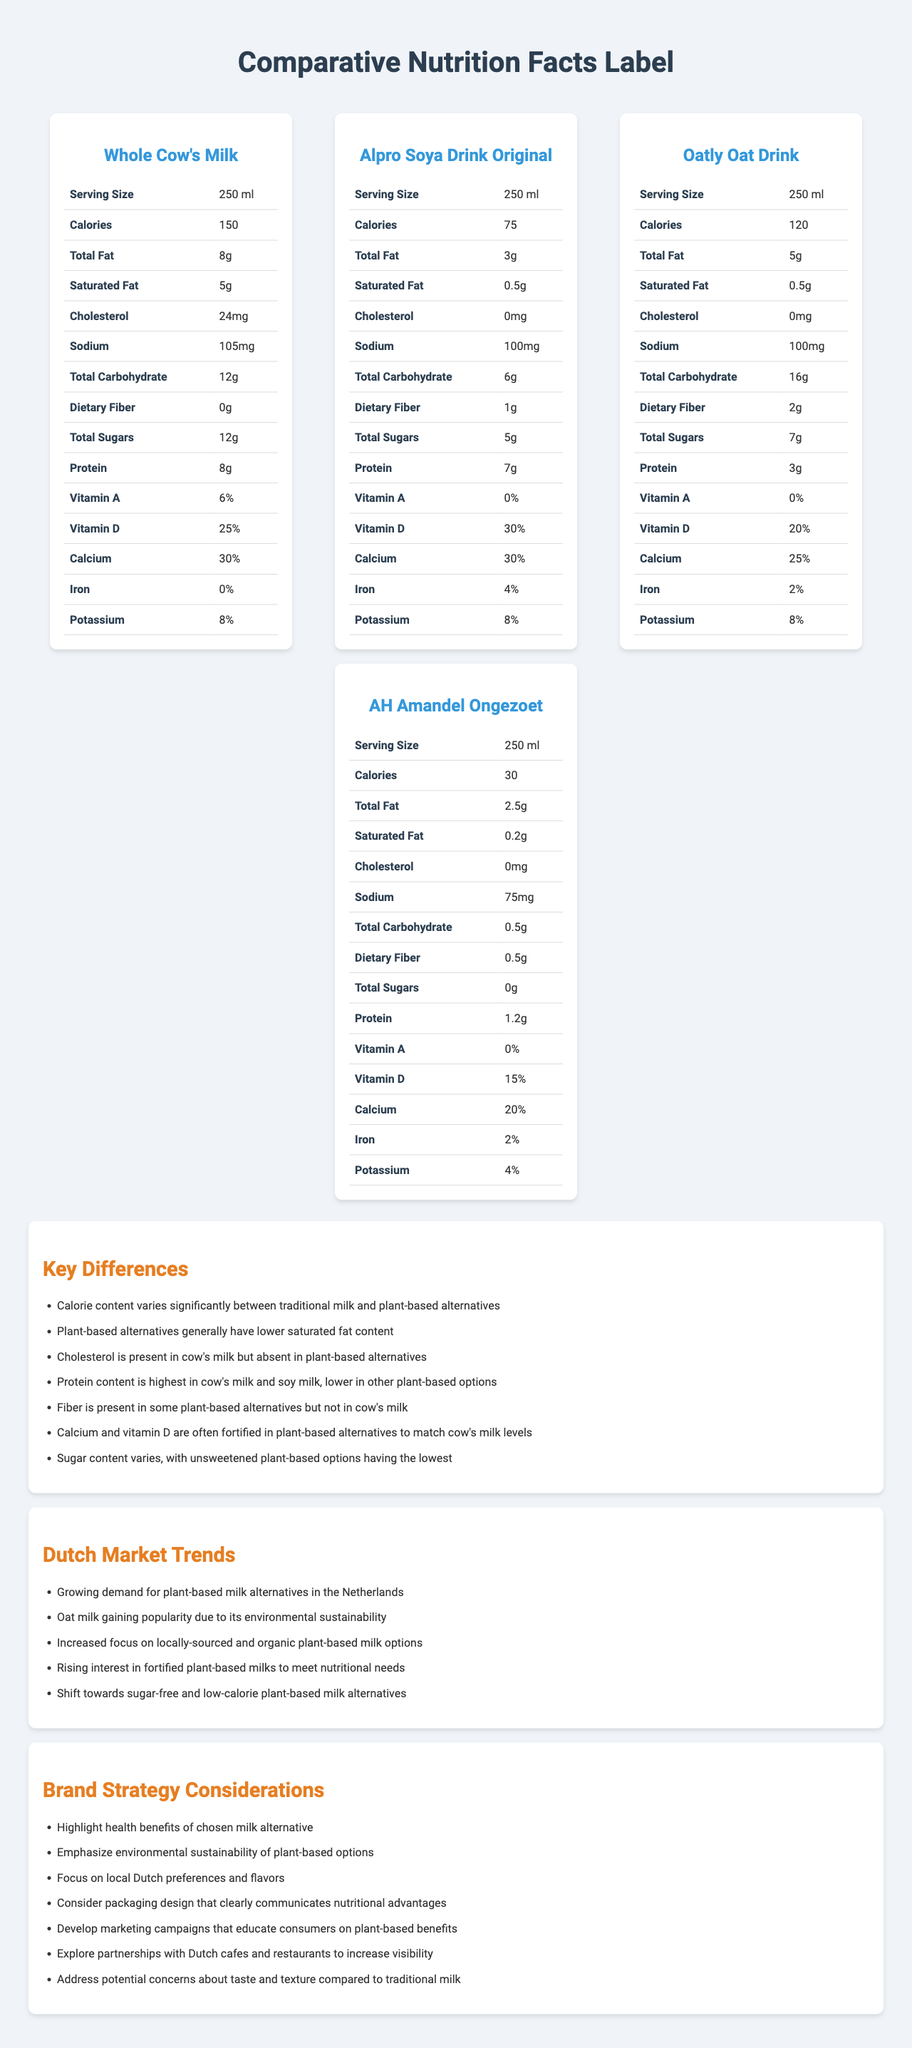What is the serving size for Whole Cow's Milk? The serving size is listed in the nutritional facts table for Whole Cow's Milk.
Answer: 250 ml Which plant-based alternative has the highest protein content? Alpro Soya Drink Original has 7g of protein per 250 ml serving, which is the highest among the plant-based alternatives listed.
Answer: Alpro Soya Drink Original How much dietary fiber does Oatly Oat Drink contain? According to the nutritional table for Oatly Oat Drink, it contains 2g of dietary fiber per serving.
Answer: 2g Does Whole Cow's Milk contain any dietary fiber? The nutritional table for Whole Cow's Milk lists dietary fiber as 0g.
Answer: No What is the total fat content of AH Amandel Ongezoet? The nutritional facts show that AH Amandel Ongezoet contains 2.5g of total fat per serving.
Answer: 2.5g Which milk option has the lowest calorie content? A. Whole Cow's Milk B. Alpro Soya Drink Original C. Oatly Oat Drink D. AH Amandel Ongezoet AH Amandel Ongezoet has 30 calories per serving, the lowest among the options listed.
Answer: D Which of the following milk alternatives is sodium content the lowest in? A. Whole Cow's Milk B. Alpro Soya Drink Original C. Oatly Oat Drink D. AH Amandel Ongezoet AH Amandel Ongezoet contains 75mg of sodium, the lowest among the listed products.
Answer: D Is cholesterol present in Oatly Oat Drink? The document states that cholesterol is 0mg in Oatly Oat Drink.
Answer: No What are the main nutritional differences between traditional milk and plant-based alternatives? The key differences section provides a detailed comparison highlighting these points.
Answer: Calorie variation, lower saturated fat, no cholesterol, higher fiber in some alternatives, differences in protein levels, fortification with calcium and vitamin D, and variable sugar content Describe the document. The document includes nutritional tables for Whole Cow's Milk and three plant-based alternatives (Alpro Soya Drink Original, Oatly Oat Drink, AH Amandel Ongezoet), explains key nutritional differences, discusses Dutch market trends for plant-based milks, and provides brand strategy considerations.
Answer: A comparative analysis of the nutrition facts labeling for Whole Cow's Milk and various plant-based milk alternatives, noting key differences, Dutch market trends, and brand strategy considerations. What is the main market trend for plant-based milk in the Netherlands? The Dutch market trends section lists "Growing demand for plant-based milk alternatives in the Netherlands" as a key trend.
Answer: Growing demand for plant-based milk alternatives Does the document provide information about the price comparison between traditional and plant-based milks? The document only addresses nutritional content, market trends, and brand strategy considerations but does not include price information.
Answer: No 